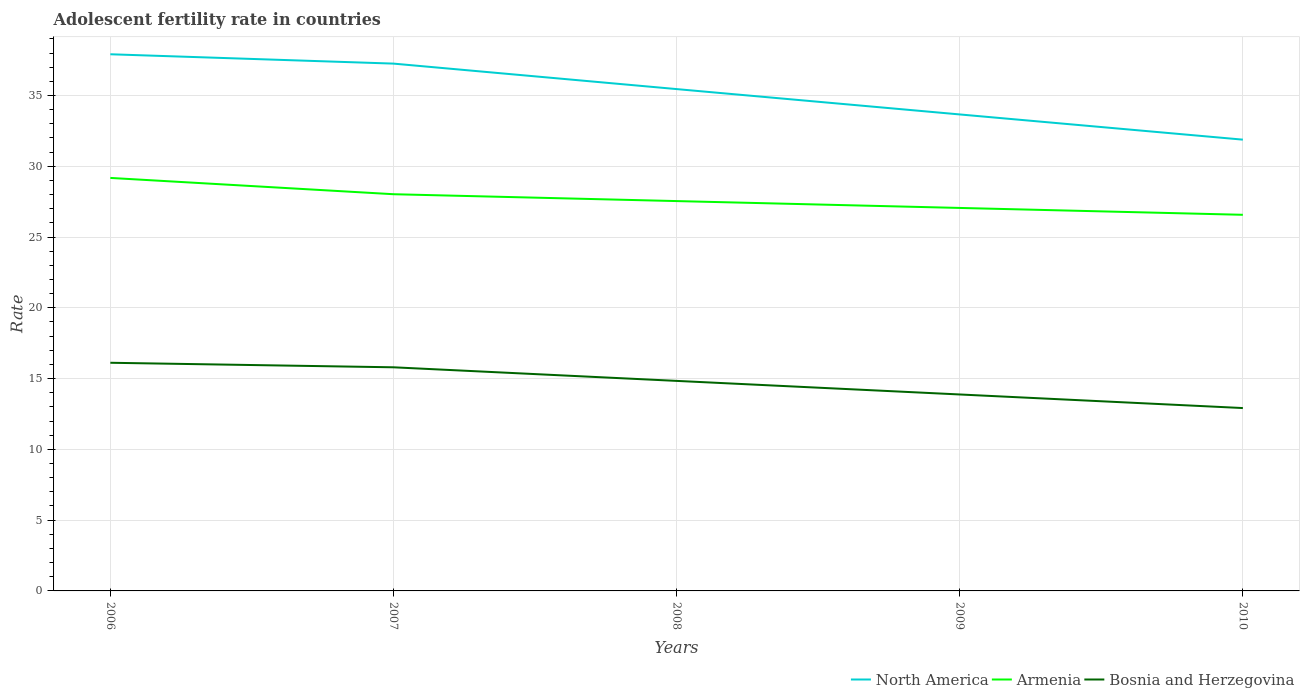How many different coloured lines are there?
Give a very brief answer. 3. Does the line corresponding to Bosnia and Herzegovina intersect with the line corresponding to Armenia?
Offer a terse response. No. Is the number of lines equal to the number of legend labels?
Your answer should be very brief. Yes. Across all years, what is the maximum adolescent fertility rate in North America?
Your answer should be very brief. 31.88. What is the total adolescent fertility rate in North America in the graph?
Offer a terse response. 5.37. What is the difference between the highest and the second highest adolescent fertility rate in Armenia?
Provide a succinct answer. 2.61. What is the difference between two consecutive major ticks on the Y-axis?
Provide a succinct answer. 5. Where does the legend appear in the graph?
Keep it short and to the point. Bottom right. How are the legend labels stacked?
Your answer should be very brief. Horizontal. What is the title of the graph?
Offer a very short reply. Adolescent fertility rate in countries. Does "Venezuela" appear as one of the legend labels in the graph?
Keep it short and to the point. No. What is the label or title of the X-axis?
Offer a very short reply. Years. What is the label or title of the Y-axis?
Provide a succinct answer. Rate. What is the Rate of North America in 2006?
Ensure brevity in your answer.  37.92. What is the Rate of Armenia in 2006?
Keep it short and to the point. 29.18. What is the Rate in Bosnia and Herzegovina in 2006?
Your answer should be compact. 16.12. What is the Rate of North America in 2007?
Offer a terse response. 37.26. What is the Rate in Armenia in 2007?
Offer a very short reply. 28.03. What is the Rate in Bosnia and Herzegovina in 2007?
Make the answer very short. 15.8. What is the Rate of North America in 2008?
Provide a short and direct response. 35.45. What is the Rate in Armenia in 2008?
Your answer should be very brief. 27.54. What is the Rate in Bosnia and Herzegovina in 2008?
Offer a terse response. 14.84. What is the Rate of North America in 2009?
Offer a terse response. 33.66. What is the Rate of Armenia in 2009?
Offer a terse response. 27.06. What is the Rate in Bosnia and Herzegovina in 2009?
Your response must be concise. 13.88. What is the Rate of North America in 2010?
Your answer should be compact. 31.88. What is the Rate of Armenia in 2010?
Your answer should be compact. 26.57. What is the Rate of Bosnia and Herzegovina in 2010?
Your answer should be compact. 12.92. Across all years, what is the maximum Rate of North America?
Keep it short and to the point. 37.92. Across all years, what is the maximum Rate in Armenia?
Provide a succinct answer. 29.18. Across all years, what is the maximum Rate in Bosnia and Herzegovina?
Ensure brevity in your answer.  16.12. Across all years, what is the minimum Rate of North America?
Your answer should be compact. 31.88. Across all years, what is the minimum Rate in Armenia?
Your response must be concise. 26.57. Across all years, what is the minimum Rate in Bosnia and Herzegovina?
Offer a terse response. 12.92. What is the total Rate of North America in the graph?
Your answer should be very brief. 176.17. What is the total Rate of Armenia in the graph?
Provide a succinct answer. 138.38. What is the total Rate of Bosnia and Herzegovina in the graph?
Give a very brief answer. 73.56. What is the difference between the Rate of North America in 2006 and that in 2007?
Ensure brevity in your answer.  0.66. What is the difference between the Rate of Armenia in 2006 and that in 2007?
Your answer should be compact. 1.15. What is the difference between the Rate of Bosnia and Herzegovina in 2006 and that in 2007?
Offer a terse response. 0.32. What is the difference between the Rate of North America in 2006 and that in 2008?
Offer a terse response. 2.46. What is the difference between the Rate in Armenia in 2006 and that in 2008?
Offer a very short reply. 1.64. What is the difference between the Rate in Bosnia and Herzegovina in 2006 and that in 2008?
Give a very brief answer. 1.28. What is the difference between the Rate of North America in 2006 and that in 2009?
Offer a terse response. 4.25. What is the difference between the Rate in Armenia in 2006 and that in 2009?
Your response must be concise. 2.12. What is the difference between the Rate in Bosnia and Herzegovina in 2006 and that in 2009?
Offer a very short reply. 2.24. What is the difference between the Rate of North America in 2006 and that in 2010?
Provide a short and direct response. 6.03. What is the difference between the Rate of Armenia in 2006 and that in 2010?
Provide a succinct answer. 2.61. What is the difference between the Rate in Bosnia and Herzegovina in 2006 and that in 2010?
Your answer should be compact. 3.2. What is the difference between the Rate of North America in 2007 and that in 2008?
Provide a succinct answer. 1.8. What is the difference between the Rate of Armenia in 2007 and that in 2008?
Give a very brief answer. 0.48. What is the difference between the Rate in Bosnia and Herzegovina in 2007 and that in 2008?
Make the answer very short. 0.96. What is the difference between the Rate in North America in 2007 and that in 2009?
Give a very brief answer. 3.59. What is the difference between the Rate in Armenia in 2007 and that in 2009?
Provide a succinct answer. 0.97. What is the difference between the Rate of Bosnia and Herzegovina in 2007 and that in 2009?
Provide a succinct answer. 1.92. What is the difference between the Rate of North America in 2007 and that in 2010?
Your answer should be very brief. 5.37. What is the difference between the Rate of Armenia in 2007 and that in 2010?
Your answer should be very brief. 1.45. What is the difference between the Rate of Bosnia and Herzegovina in 2007 and that in 2010?
Offer a terse response. 2.88. What is the difference between the Rate in North America in 2008 and that in 2009?
Ensure brevity in your answer.  1.79. What is the difference between the Rate in Armenia in 2008 and that in 2009?
Your response must be concise. 0.48. What is the difference between the Rate in Bosnia and Herzegovina in 2008 and that in 2009?
Give a very brief answer. 0.96. What is the difference between the Rate of North America in 2008 and that in 2010?
Your answer should be very brief. 3.57. What is the difference between the Rate of Armenia in 2008 and that in 2010?
Offer a terse response. 0.97. What is the difference between the Rate of Bosnia and Herzegovina in 2008 and that in 2010?
Keep it short and to the point. 1.92. What is the difference between the Rate of North America in 2009 and that in 2010?
Ensure brevity in your answer.  1.78. What is the difference between the Rate of Armenia in 2009 and that in 2010?
Make the answer very short. 0.48. What is the difference between the Rate in Bosnia and Herzegovina in 2009 and that in 2010?
Give a very brief answer. 0.96. What is the difference between the Rate of North America in 2006 and the Rate of Armenia in 2007?
Your answer should be very brief. 9.89. What is the difference between the Rate of North America in 2006 and the Rate of Bosnia and Herzegovina in 2007?
Your answer should be compact. 22.12. What is the difference between the Rate in Armenia in 2006 and the Rate in Bosnia and Herzegovina in 2007?
Give a very brief answer. 13.38. What is the difference between the Rate of North America in 2006 and the Rate of Armenia in 2008?
Offer a very short reply. 10.37. What is the difference between the Rate of North America in 2006 and the Rate of Bosnia and Herzegovina in 2008?
Provide a short and direct response. 23.08. What is the difference between the Rate in Armenia in 2006 and the Rate in Bosnia and Herzegovina in 2008?
Your answer should be very brief. 14.34. What is the difference between the Rate in North America in 2006 and the Rate in Armenia in 2009?
Provide a succinct answer. 10.86. What is the difference between the Rate in North America in 2006 and the Rate in Bosnia and Herzegovina in 2009?
Your answer should be compact. 24.04. What is the difference between the Rate in Armenia in 2006 and the Rate in Bosnia and Herzegovina in 2009?
Keep it short and to the point. 15.3. What is the difference between the Rate in North America in 2006 and the Rate in Armenia in 2010?
Your answer should be compact. 11.34. What is the difference between the Rate of North America in 2006 and the Rate of Bosnia and Herzegovina in 2010?
Give a very brief answer. 25. What is the difference between the Rate of Armenia in 2006 and the Rate of Bosnia and Herzegovina in 2010?
Provide a short and direct response. 16.26. What is the difference between the Rate in North America in 2007 and the Rate in Armenia in 2008?
Your answer should be compact. 9.71. What is the difference between the Rate in North America in 2007 and the Rate in Bosnia and Herzegovina in 2008?
Provide a short and direct response. 22.42. What is the difference between the Rate of Armenia in 2007 and the Rate of Bosnia and Herzegovina in 2008?
Provide a succinct answer. 13.19. What is the difference between the Rate in North America in 2007 and the Rate in Armenia in 2009?
Provide a short and direct response. 10.2. What is the difference between the Rate in North America in 2007 and the Rate in Bosnia and Herzegovina in 2009?
Offer a terse response. 23.38. What is the difference between the Rate of Armenia in 2007 and the Rate of Bosnia and Herzegovina in 2009?
Provide a short and direct response. 14.15. What is the difference between the Rate of North America in 2007 and the Rate of Armenia in 2010?
Your response must be concise. 10.68. What is the difference between the Rate of North America in 2007 and the Rate of Bosnia and Herzegovina in 2010?
Offer a very short reply. 24.34. What is the difference between the Rate of Armenia in 2007 and the Rate of Bosnia and Herzegovina in 2010?
Provide a succinct answer. 15.11. What is the difference between the Rate in North America in 2008 and the Rate in Armenia in 2009?
Offer a very short reply. 8.4. What is the difference between the Rate in North America in 2008 and the Rate in Bosnia and Herzegovina in 2009?
Keep it short and to the point. 21.58. What is the difference between the Rate in Armenia in 2008 and the Rate in Bosnia and Herzegovina in 2009?
Give a very brief answer. 13.66. What is the difference between the Rate of North America in 2008 and the Rate of Armenia in 2010?
Your answer should be compact. 8.88. What is the difference between the Rate in North America in 2008 and the Rate in Bosnia and Herzegovina in 2010?
Offer a very short reply. 22.54. What is the difference between the Rate of Armenia in 2008 and the Rate of Bosnia and Herzegovina in 2010?
Provide a succinct answer. 14.62. What is the difference between the Rate of North America in 2009 and the Rate of Armenia in 2010?
Your answer should be compact. 7.09. What is the difference between the Rate in North America in 2009 and the Rate in Bosnia and Herzegovina in 2010?
Your response must be concise. 20.74. What is the difference between the Rate of Armenia in 2009 and the Rate of Bosnia and Herzegovina in 2010?
Make the answer very short. 14.14. What is the average Rate of North America per year?
Keep it short and to the point. 35.23. What is the average Rate of Armenia per year?
Offer a very short reply. 27.68. What is the average Rate in Bosnia and Herzegovina per year?
Offer a very short reply. 14.71. In the year 2006, what is the difference between the Rate of North America and Rate of Armenia?
Keep it short and to the point. 8.74. In the year 2006, what is the difference between the Rate in North America and Rate in Bosnia and Herzegovina?
Ensure brevity in your answer.  21.8. In the year 2006, what is the difference between the Rate of Armenia and Rate of Bosnia and Herzegovina?
Provide a short and direct response. 13.06. In the year 2007, what is the difference between the Rate of North America and Rate of Armenia?
Your response must be concise. 9.23. In the year 2007, what is the difference between the Rate of North America and Rate of Bosnia and Herzegovina?
Ensure brevity in your answer.  21.46. In the year 2007, what is the difference between the Rate in Armenia and Rate in Bosnia and Herzegovina?
Keep it short and to the point. 12.23. In the year 2008, what is the difference between the Rate of North America and Rate of Armenia?
Offer a very short reply. 7.91. In the year 2008, what is the difference between the Rate in North America and Rate in Bosnia and Herzegovina?
Keep it short and to the point. 20.62. In the year 2008, what is the difference between the Rate in Armenia and Rate in Bosnia and Herzegovina?
Give a very brief answer. 12.7. In the year 2009, what is the difference between the Rate of North America and Rate of Armenia?
Provide a succinct answer. 6.61. In the year 2009, what is the difference between the Rate in North America and Rate in Bosnia and Herzegovina?
Ensure brevity in your answer.  19.78. In the year 2009, what is the difference between the Rate of Armenia and Rate of Bosnia and Herzegovina?
Give a very brief answer. 13.18. In the year 2010, what is the difference between the Rate in North America and Rate in Armenia?
Your answer should be very brief. 5.31. In the year 2010, what is the difference between the Rate of North America and Rate of Bosnia and Herzegovina?
Provide a short and direct response. 18.96. In the year 2010, what is the difference between the Rate of Armenia and Rate of Bosnia and Herzegovina?
Your answer should be compact. 13.65. What is the ratio of the Rate of North America in 2006 to that in 2007?
Give a very brief answer. 1.02. What is the ratio of the Rate of Armenia in 2006 to that in 2007?
Your answer should be very brief. 1.04. What is the ratio of the Rate in Bosnia and Herzegovina in 2006 to that in 2007?
Your answer should be compact. 1.02. What is the ratio of the Rate of North America in 2006 to that in 2008?
Give a very brief answer. 1.07. What is the ratio of the Rate of Armenia in 2006 to that in 2008?
Provide a succinct answer. 1.06. What is the ratio of the Rate in Bosnia and Herzegovina in 2006 to that in 2008?
Make the answer very short. 1.09. What is the ratio of the Rate in North America in 2006 to that in 2009?
Provide a succinct answer. 1.13. What is the ratio of the Rate of Armenia in 2006 to that in 2009?
Your response must be concise. 1.08. What is the ratio of the Rate of Bosnia and Herzegovina in 2006 to that in 2009?
Give a very brief answer. 1.16. What is the ratio of the Rate of North America in 2006 to that in 2010?
Your response must be concise. 1.19. What is the ratio of the Rate in Armenia in 2006 to that in 2010?
Your answer should be compact. 1.1. What is the ratio of the Rate of Bosnia and Herzegovina in 2006 to that in 2010?
Your response must be concise. 1.25. What is the ratio of the Rate of North America in 2007 to that in 2008?
Offer a terse response. 1.05. What is the ratio of the Rate in Armenia in 2007 to that in 2008?
Offer a terse response. 1.02. What is the ratio of the Rate of Bosnia and Herzegovina in 2007 to that in 2008?
Make the answer very short. 1.06. What is the ratio of the Rate in North America in 2007 to that in 2009?
Give a very brief answer. 1.11. What is the ratio of the Rate in Armenia in 2007 to that in 2009?
Make the answer very short. 1.04. What is the ratio of the Rate of Bosnia and Herzegovina in 2007 to that in 2009?
Your answer should be very brief. 1.14. What is the ratio of the Rate in North America in 2007 to that in 2010?
Offer a terse response. 1.17. What is the ratio of the Rate in Armenia in 2007 to that in 2010?
Your answer should be very brief. 1.05. What is the ratio of the Rate of Bosnia and Herzegovina in 2007 to that in 2010?
Ensure brevity in your answer.  1.22. What is the ratio of the Rate in North America in 2008 to that in 2009?
Keep it short and to the point. 1.05. What is the ratio of the Rate of Armenia in 2008 to that in 2009?
Ensure brevity in your answer.  1.02. What is the ratio of the Rate of Bosnia and Herzegovina in 2008 to that in 2009?
Offer a terse response. 1.07. What is the ratio of the Rate in North America in 2008 to that in 2010?
Give a very brief answer. 1.11. What is the ratio of the Rate of Armenia in 2008 to that in 2010?
Keep it short and to the point. 1.04. What is the ratio of the Rate of Bosnia and Herzegovina in 2008 to that in 2010?
Your answer should be compact. 1.15. What is the ratio of the Rate of North America in 2009 to that in 2010?
Keep it short and to the point. 1.06. What is the ratio of the Rate in Armenia in 2009 to that in 2010?
Ensure brevity in your answer.  1.02. What is the ratio of the Rate of Bosnia and Herzegovina in 2009 to that in 2010?
Offer a terse response. 1.07. What is the difference between the highest and the second highest Rate of North America?
Offer a terse response. 0.66. What is the difference between the highest and the second highest Rate of Armenia?
Offer a very short reply. 1.15. What is the difference between the highest and the second highest Rate in Bosnia and Herzegovina?
Offer a terse response. 0.32. What is the difference between the highest and the lowest Rate of North America?
Offer a very short reply. 6.03. What is the difference between the highest and the lowest Rate of Armenia?
Your response must be concise. 2.61. What is the difference between the highest and the lowest Rate in Bosnia and Herzegovina?
Give a very brief answer. 3.2. 